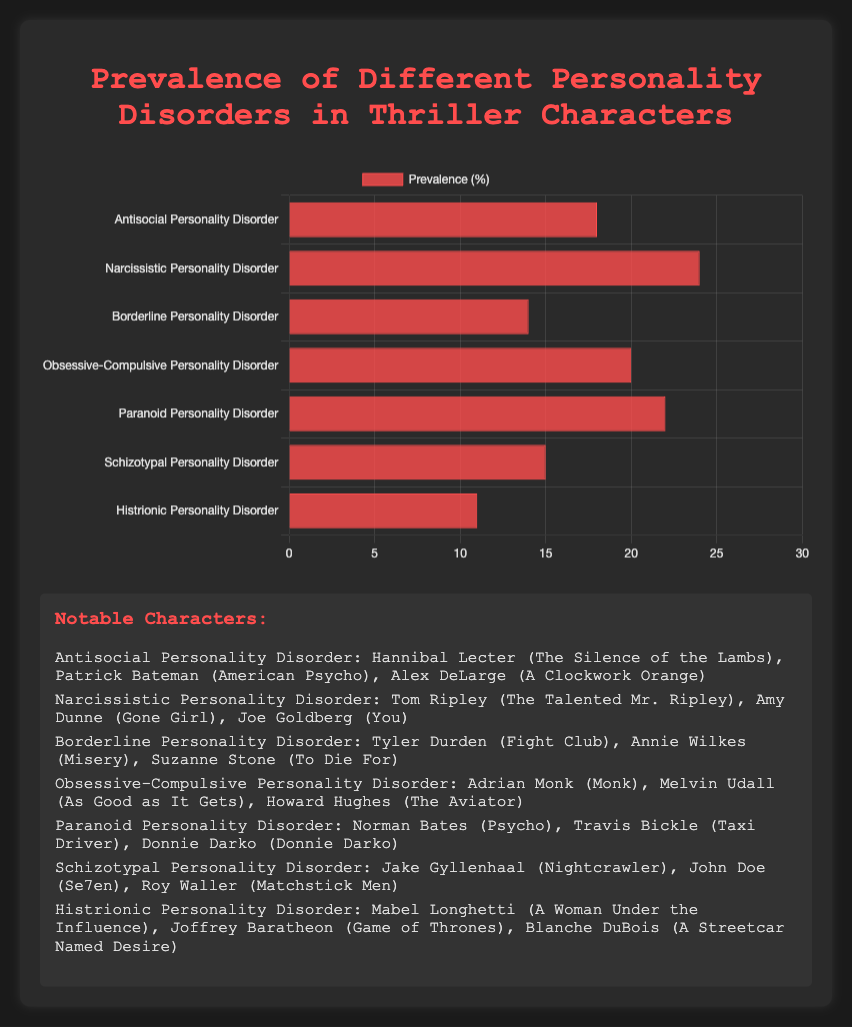Which personality disorder has the highest prevalence? Look at the length of the bars in the chart, the longest bar represents Narcissistic Personality Disorder with a prevalence of 24%.
Answer: Narcissistic Personality Disorder Which disorder is more prevalent, Paranoid Personality Disorder or Antisocial Personality Disorder? Compare the lengths of the bars for the two disorders; Paranoid Personality Disorder is longer at 22% compared to 18% for Antisocial Personality Disorder.
Answer: Paranoid Personality Disorder What is the combined prevalence of Antisocial and Borderline Personality Disorders? Sum the prevalence values for Antisocial (18%) and Borderline (14%). 18 + 14 = 32%
Answer: 32% Which character is associated with Obsessive-Compulsive Personality Disorder? Refer to the character list provided: Adrian Monk, Melvin Udall, and Howard Hughes are associated with Obsessive-Compulsive Personality Disorder.
Answer: Adrian Monk, Melvin Udall, Howard Hughes Is the prevalence of Schizotypal Personality Disorder higher or lower than Histrionic Personality Disorder? Compare the bar lengths; Schizotypal Personality Disorder (15%) is higher than Histrionic Personality Disorder (11%).
Answer: Higher What is the average prevalence of all listed personality disorders? Sum all the prevalence values: 18 + 24 + 14 + 20 + 22 + 15 + 11 = 124. Divide by the number of disorders (7). 124 / 7 ≈ 17.71%
Answer: 17.71% Which personality disorder is least prevalent among thriller characters? Look for the shortest bar in the chart; Histrionic Personality Disorder has the shortest bar with a prevalence of 11%.
Answer: Histrionic Personality Disorder How does the prevalence of Narcissistic Personality Disorder compare to Obsessive-Compulsive Personality Disorder? Compare their prevalence values; Narcissistic Personality Disorder (24%) is higher than Obsessive-Compulsive Personality Disorder (20%).
Answer: Higher What is the difference in prevalence between Paranoid Personality Disorder and Borderline Personality Disorder? Subtract the prevalence of Borderline Personality Disorder (14%) from Paranoid Personality Disorder (22%). 22 - 14 = 8%
Answer: 8% Which disorder's bar length appears closest to the average prevalence of all disorders? Calculate the average prevalence (17.71%), and compare the bar lengths; Antisocial Personality Disorder at 18% is closest.
Answer: Antisocial Personality Disorder 